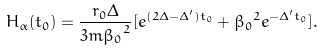Convert formula to latex. <formula><loc_0><loc_0><loc_500><loc_500>H _ { \alpha } ( t _ { 0 } ) = { \frac { r _ { 0 } \Delta } { 3 m { \beta _ { 0 } } ^ { 2 } } } [ e ^ { ( 2 \Delta - \Delta ^ { \prime } ) t _ { 0 } } + { \beta _ { 0 } } ^ { 2 } e ^ { - \Delta ^ { \prime } t _ { 0 } } ] .</formula> 